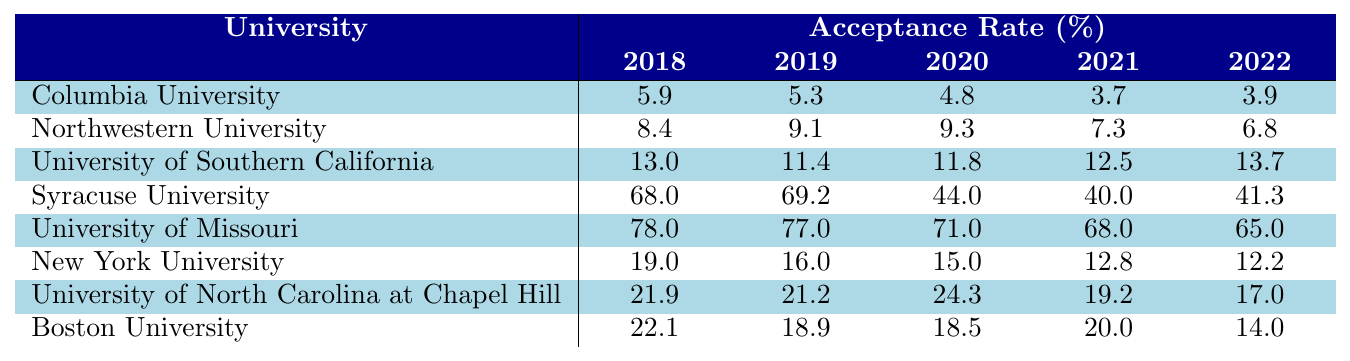What is the acceptance rate for Columbia University in 2022? In the table, the acceptance rate for Columbia University for the year 2022 is directly listed as 3.9%.
Answer: 3.9% Which university had the highest acceptance rate in 2021? Looking at the table, Syracuse University has the highest acceptance rate listed for 2021 at 40.0%.
Answer: Syracuse University What was the trend for acceptance rates at Northwestern University from 2018 to 2022? The acceptance rates for Northwestern University are as follows: 8.4% (2018), 9.1% (2019), 9.3% (2020), 7.3% (2021), and 6.8% (2022). The trend shows a decrease from 2018, peaking in 2020, then declining to 6.8% in 2022.
Answer: Decreasing trend What is the average acceptance rate for the University of Southern California from 2018 to 2022? The acceptance rates are 13.0%, 11.4%, 11.8%, 12.5%, and 13.7%. Summing these gives 62.4%. Dividing by 5 gives an average of 12.48%.
Answer: 12.48% Did New York University ever have an acceptance rate above 18% from 2018 to 2022? The acceptance rates for New York University are 19.0% (2018), 16.0% (2019), 15.0% (2020), 12.8% (2021), and 12.2% (2022). The rate is above 18% only in 2018, so the answer is yes.
Answer: Yes Which university consistently had the lowest acceptance rates from 2018 to 2022? By reviewing the acceptance rates for each university over the years, Columbia University has the lowest acceptance rates at 5.9%, 5.3%, 4.8%, 3.7%, and 3.9%, clearly being the lowest consistently.
Answer: Columbia University What was the difference in acceptance rates between the University of Missouri and Boston University in 2022? The acceptance rate for the University of Missouri in 2022 was 65.0%, and for Boston University, it was 14.0%. The difference is 65.0% - 14.0% = 51.0%.
Answer: 51.0% How does the average acceptance rate for Syracuse University compare to that of the University of North Carolina at Chapel Hill over the five years? The average for Syracuse University is (68.0 + 69.2 + 44.0 + 40.0 + 41.3) / 5 = 52.1%. For UNC, it's (21.9 + 21.2 + 24.3 + 19.2 + 17.0) / 5 = 20.92%. Thus, Syracuse has a higher average acceptance rate of 52.1% vs. 20.92%.
Answer: Syracuse University has a higher average acceptance rate Is there any year when the acceptance rate for Boston University fell below 18%? The acceptance rates for Boston University are 22.1% (2018), 18.9% (2019), 18.5% (2020), 20.0% (2021), and 14.0% (2022). The rate fell below 18% in 2022, confirming it's true.
Answer: Yes What was the maximum acceptance rate for any university in the data set from 2018 to 2022? Reviewing the highest values from each university in that period, Syracuse University in 2018 had the maximum acceptance rate at 68.0%.
Answer: 68.0% 